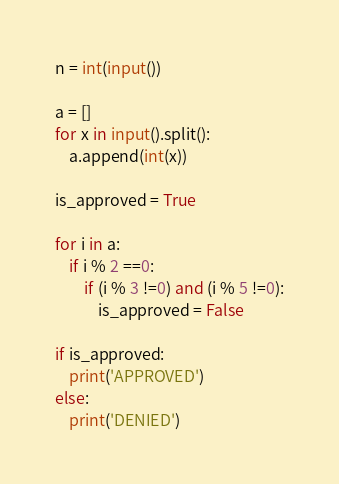<code> <loc_0><loc_0><loc_500><loc_500><_Python_>n = int(input())

a = []
for x in input().split():
    a.append(int(x))
    
is_approved = True

for i in a:
    if i % 2 ==0:
        if (i % 3 !=0) and (i % 5 !=0):
            is_approved = False
            
if is_approved:
    print('APPROVED')
else:
    print('DENIED')</code> 